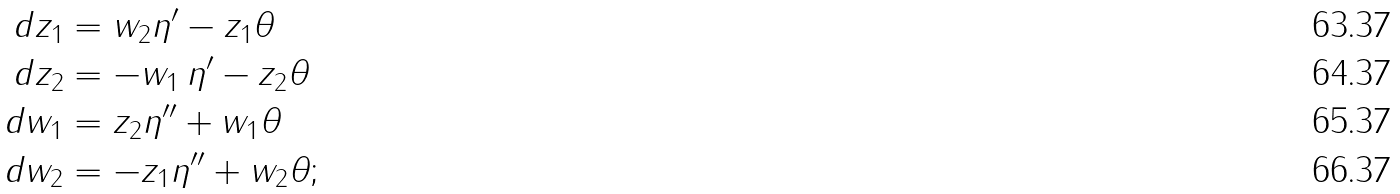<formula> <loc_0><loc_0><loc_500><loc_500>d z _ { 1 } & = w _ { 2 } \eta ^ { \prime } - z _ { 1 } \theta \\ d z _ { 2 } & = - w _ { 1 } \, \eta ^ { \prime } - z _ { 2 } \theta \\ d w _ { 1 } & = z _ { 2 } \eta ^ { \prime \prime } + w _ { 1 } \theta \\ d w _ { 2 } & = - z _ { 1 } \eta ^ { \prime \prime } + w _ { 2 } \theta ;</formula> 